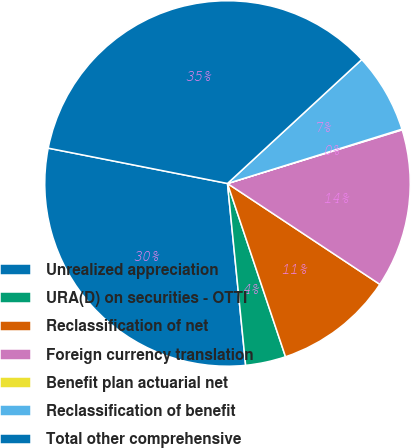<chart> <loc_0><loc_0><loc_500><loc_500><pie_chart><fcel>Unrealized appreciation<fcel>URA(D) on securities - OTTI<fcel>Reclassification of net<fcel>Foreign currency translation<fcel>Benefit plan actuarial net<fcel>Reclassification of benefit<fcel>Total other comprehensive<nl><fcel>29.68%<fcel>3.56%<fcel>10.55%<fcel>14.05%<fcel>0.06%<fcel>7.06%<fcel>35.04%<nl></chart> 